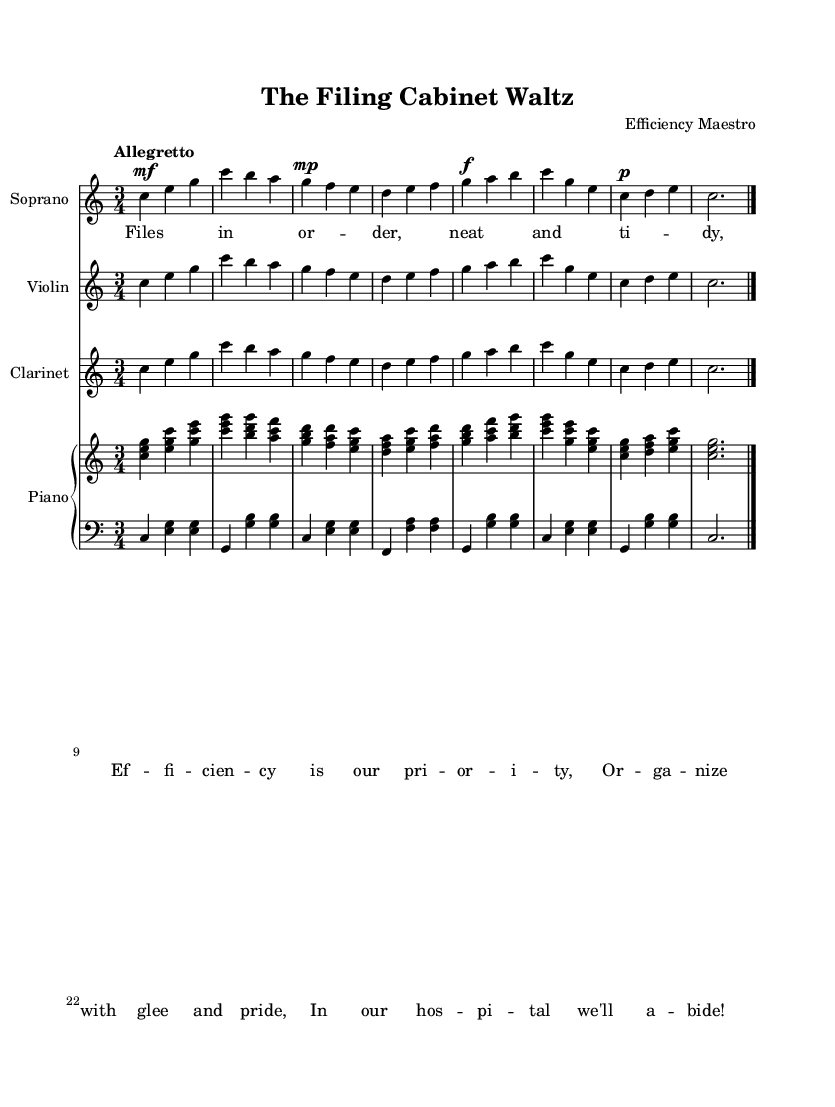What is the title of this piece? The title is provided in the header section of the sheet music, which states "The Filing Cabinet Waltz."
Answer: The Filing Cabinet Waltz What is the key signature of this music? The key signature is indicated in the global settings of the sheet music as C major, which has no sharps or flats.
Answer: C major What is the time signature of this piece? The time signature is found in the global section, and it is indicated as 3/4 time, which means there are three beats per measure.
Answer: 3/4 What is the tempo marking for this piece? The tempo is specified in the global section and is marked as "Allegretto," suggesting a moderately fast pace.
Answer: Allegretto How many measures are there in the soprano part? By counting the number of bar lines in the soprano part, there are a total of 8 measures throughout the score.
Answer: 8 Why is this piece categorized as an operetta? The context of the piece, entitled "The Filing Cabinet Waltz," incorporates light-hearted themes and focuses on workplace efficiency, which is characteristic of operettas that often include humor and social commentary.
Answer: Light-hearted themes What is the dynamic marking for the first vocal line? The first vocal line starts with a dynamic marking of mezzo-forte (mf), indicating a moderately loud sound.
Answer: mezzo-forte 